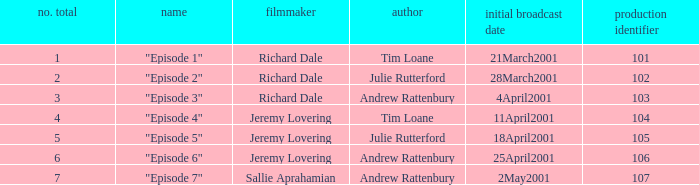When did the episode first air that had a production code of 102? 28March2001. 